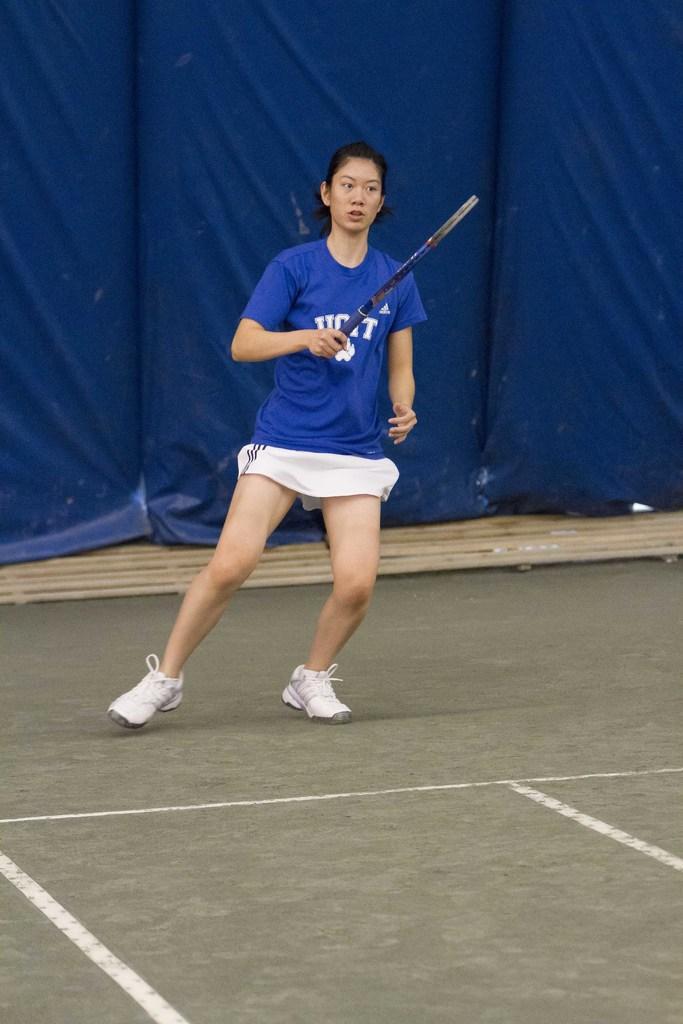Can you describe this image briefly? a person is standing, holding a racket in her hand. she is wearing a blue t shirt. behind her there are blue curtains. 